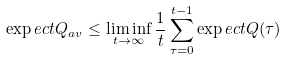Convert formula to latex. <formula><loc_0><loc_0><loc_500><loc_500>\exp e c t { Q _ { a v } } \leq \liminf _ { t \rightarrow \infty } \frac { 1 } { t } \sum _ { \tau = 0 } ^ { t - 1 } \exp e c t { Q ( \tau ) }</formula> 